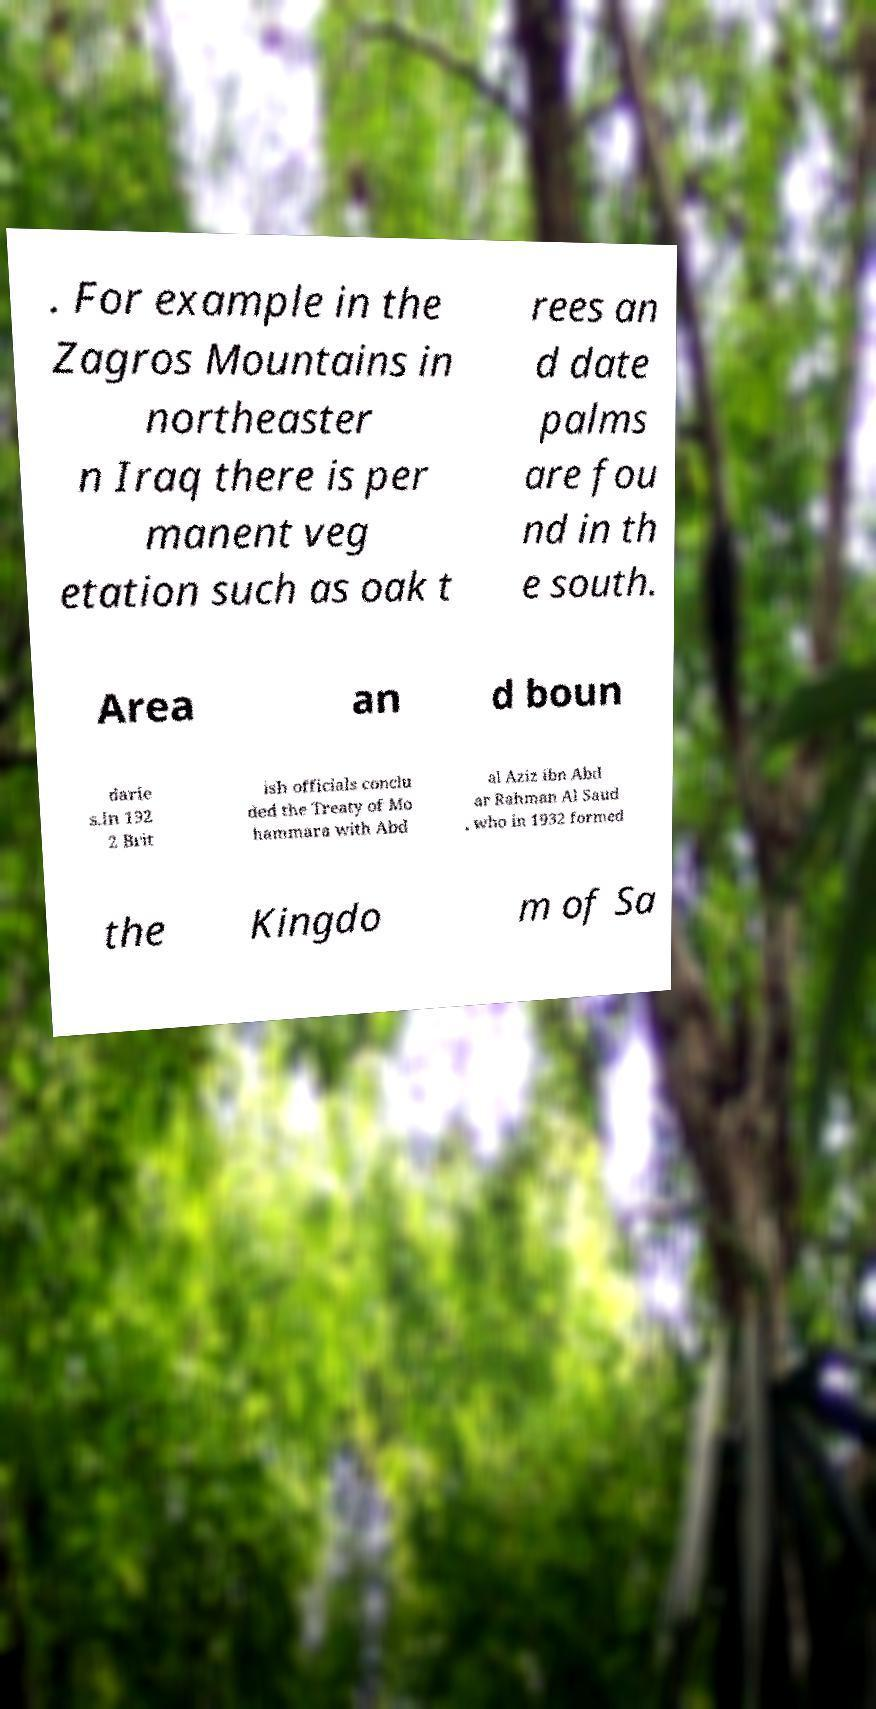Please read and relay the text visible in this image. What does it say? . For example in the Zagros Mountains in northeaster n Iraq there is per manent veg etation such as oak t rees an d date palms are fou nd in th e south. Area an d boun darie s.In 192 2 Brit ish officials conclu ded the Treaty of Mo hammara with Abd al Aziz ibn Abd ar Rahman Al Saud , who in 1932 formed the Kingdo m of Sa 